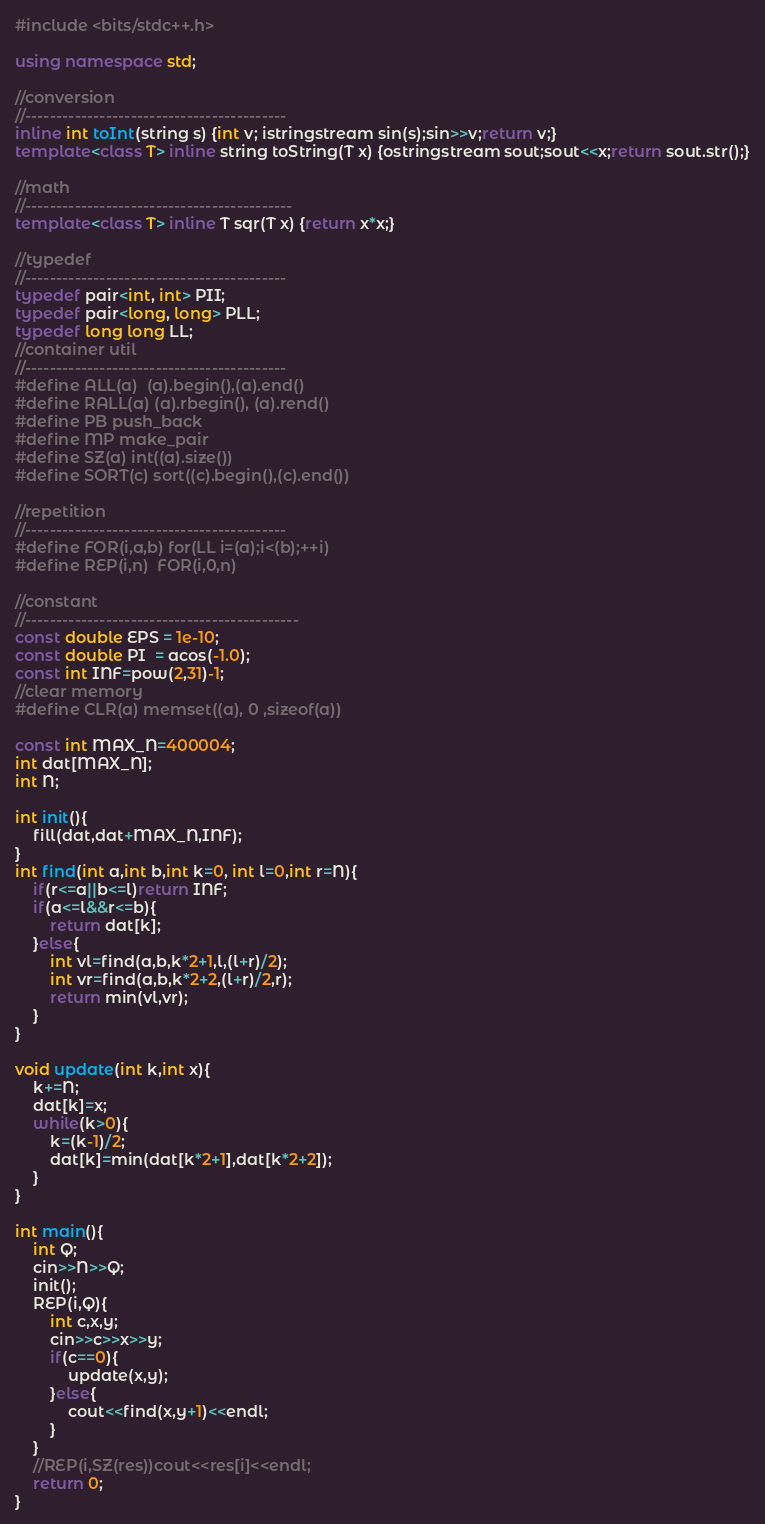Convert code to text. <code><loc_0><loc_0><loc_500><loc_500><_C++_>#include <bits/stdc++.h>
 
using namespace std;
 
//conversion
//------------------------------------------
inline int toInt(string s) {int v; istringstream sin(s);sin>>v;return v;}
template<class T> inline string toString(T x) {ostringstream sout;sout<<x;return sout.str();}
 
//math
//-------------------------------------------
template<class T> inline T sqr(T x) {return x*x;}
 
//typedef
//------------------------------------------
typedef pair<int, int> PII;
typedef pair<long, long> PLL;
typedef long long LL;
//container util
//------------------------------------------
#define ALL(a)  (a).begin(),(a).end()
#define RALL(a) (a).rbegin(), (a).rend()
#define PB push_back
#define MP make_pair
#define SZ(a) int((a).size())
#define SORT(c) sort((c).begin(),(c).end())
 
//repetition
//------------------------------------------
#define FOR(i,a,b) for(LL i=(a);i<(b);++i)
#define REP(i,n)  FOR(i,0,n)
 
//constant
//--------------------------------------------
const double EPS = 1e-10;
const double PI  = acos(-1.0);
const int INF=pow(2,31)-1;
//clear memory
#define CLR(a) memset((a), 0 ,sizeof(a))
 
const int MAX_N=400004;
int dat[MAX_N];
int N;

int init(){
	fill(dat,dat+MAX_N,INF);
}
int find(int a,int b,int k=0, int l=0,int r=N){
	if(r<=a||b<=l)return INF;
	if(a<=l&&r<=b){
		return dat[k];
	}else{
		int vl=find(a,b,k*2+1,l,(l+r)/2);
		int vr=find(a,b,k*2+2,(l+r)/2,r);
		return min(vl,vr);
	}
}

void update(int k,int x){
	k+=N;
	dat[k]=x;
	while(k>0){
		k=(k-1)/2;
		dat[k]=min(dat[k*2+1],dat[k*2+2]);
	}
}

int main(){
	int Q;
	cin>>N>>Q;
	init();
	REP(i,Q){
		int c,x,y;
		cin>>c>>x>>y;
		if(c==0){
			update(x,y);
		}else{
			cout<<find(x,y+1)<<endl;
		}
	}
	//REP(i,SZ(res))cout<<res[i]<<endl;
	return 0;
}</code> 